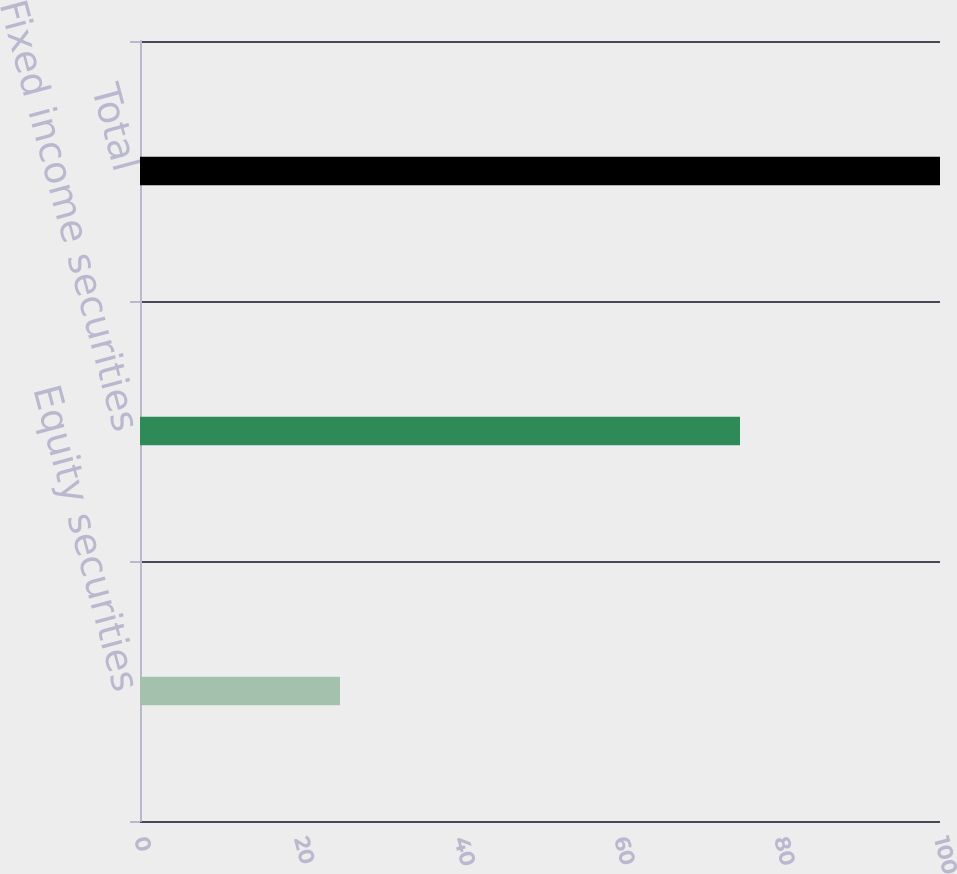<chart> <loc_0><loc_0><loc_500><loc_500><bar_chart><fcel>Equity securities<fcel>Fixed income securities<fcel>Total<nl><fcel>25<fcel>75<fcel>100<nl></chart> 